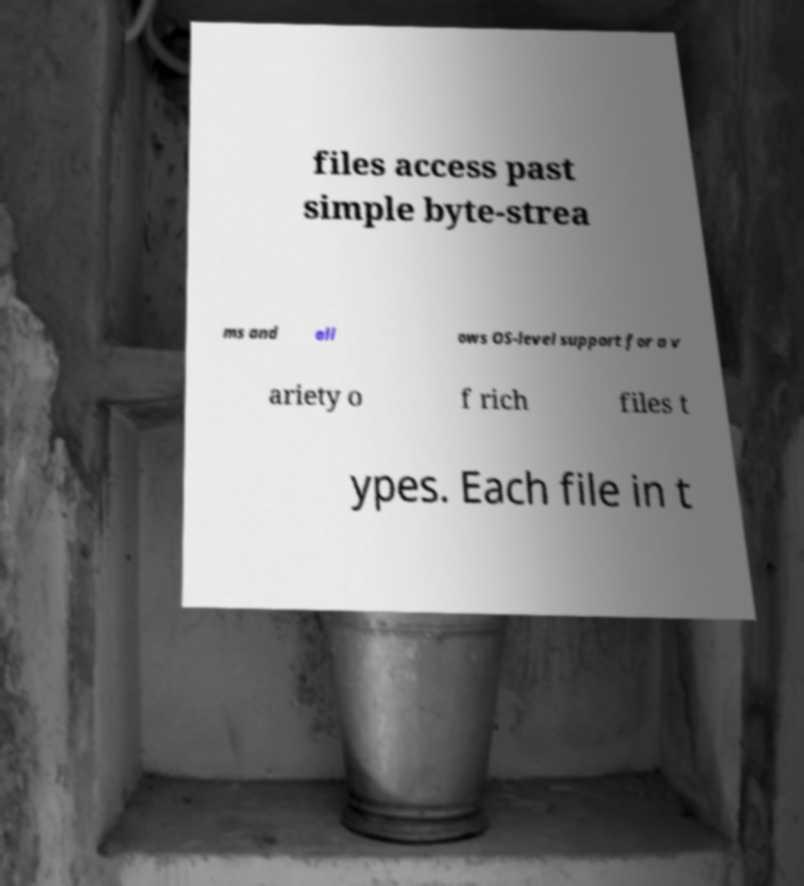Please identify and transcribe the text found in this image. files access past simple byte-strea ms and all ows OS-level support for a v ariety o f rich files t ypes. Each file in t 